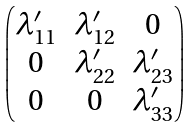Convert formula to latex. <formula><loc_0><loc_0><loc_500><loc_500>\begin{pmatrix} \lambda ^ { \prime } _ { 1 1 } & \lambda ^ { \prime } _ { 1 2 } & 0 \\ 0 & \lambda ^ { \prime } _ { 2 2 } & \lambda ^ { \prime } _ { 2 3 } \\ 0 & 0 & \lambda ^ { \prime } _ { 3 3 } \end{pmatrix}</formula> 